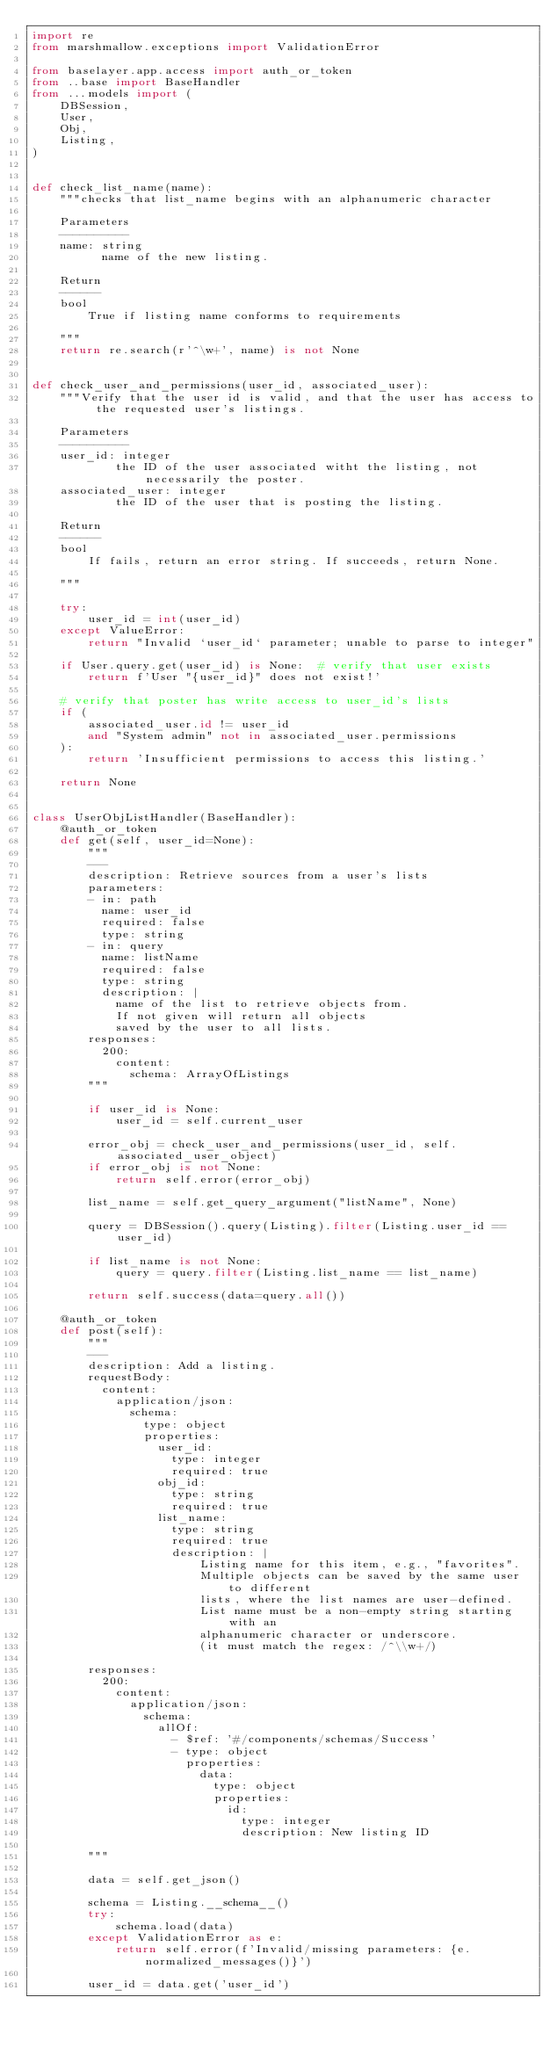<code> <loc_0><loc_0><loc_500><loc_500><_Python_>import re
from marshmallow.exceptions import ValidationError

from baselayer.app.access import auth_or_token
from ..base import BaseHandler
from ...models import (
    DBSession,
    User,
    Obj,
    Listing,
)


def check_list_name(name):
    """checks that list_name begins with an alphanumeric character

    Parameters
    ----------
    name: string
          name of the new listing.

    Return
    ------
    bool
        True if listing name conforms to requirements

    """
    return re.search(r'^\w+', name) is not None


def check_user_and_permissions(user_id, associated_user):
    """Verify that the user id is valid, and that the user has access to the requested user's listings.

    Parameters
    ----------
    user_id: integer
            the ID of the user associated witht the listing, not necessarily the poster.
    associated_user: integer
            the ID of the user that is posting the listing.

    Return
    ------
    bool
        If fails, return an error string. If succeeds, return None.

    """

    try:
        user_id = int(user_id)
    except ValueError:
        return "Invalid `user_id` parameter; unable to parse to integer"

    if User.query.get(user_id) is None:  # verify that user exists
        return f'User "{user_id}" does not exist!'

    # verify that poster has write access to user_id's lists
    if (
        associated_user.id != user_id
        and "System admin" not in associated_user.permissions
    ):
        return 'Insufficient permissions to access this listing.'

    return None


class UserObjListHandler(BaseHandler):
    @auth_or_token
    def get(self, user_id=None):
        """
        ---
        description: Retrieve sources from a user's lists
        parameters:
        - in: path
          name: user_id
          required: false
          type: string
        - in: query
          name: listName
          required: false
          type: string
          description: |
            name of the list to retrieve objects from.
            If not given will return all objects
            saved by the user to all lists.
        responses:
          200:
            content:
              schema: ArrayOfListings
        """

        if user_id is None:
            user_id = self.current_user

        error_obj = check_user_and_permissions(user_id, self.associated_user_object)
        if error_obj is not None:
            return self.error(error_obj)

        list_name = self.get_query_argument("listName", None)

        query = DBSession().query(Listing).filter(Listing.user_id == user_id)

        if list_name is not None:
            query = query.filter(Listing.list_name == list_name)

        return self.success(data=query.all())

    @auth_or_token
    def post(self):
        """
        ---
        description: Add a listing.
        requestBody:
          content:
            application/json:
              schema:
                type: object
                properties:
                  user_id:
                    type: integer
                    required: true
                  obj_id:
                    type: string
                    required: true
                  list_name:
                    type: string
                    required: true
                    description: |
                        Listing name for this item, e.g., "favorites".
                        Multiple objects can be saved by the same user to different
                        lists, where the list names are user-defined.
                        List name must be a non-empty string starting with an
                        alphanumeric character or underscore.
                        (it must match the regex: /^\\w+/)

        responses:
          200:
            content:
              application/json:
                schema:
                  allOf:
                    - $ref: '#/components/schemas/Success'
                    - type: object
                      properties:
                        data:
                          type: object
                          properties:
                            id:
                              type: integer
                              description: New listing ID

        """

        data = self.get_json()

        schema = Listing.__schema__()
        try:
            schema.load(data)
        except ValidationError as e:
            return self.error(f'Invalid/missing parameters: {e.normalized_messages()}')

        user_id = data.get('user_id')
</code> 